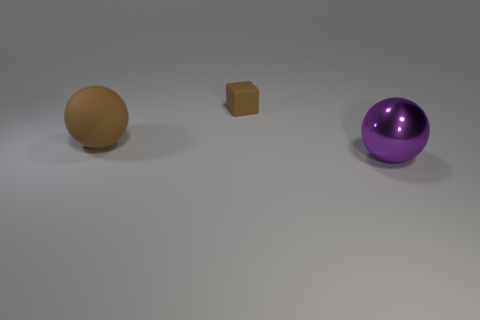Is there anything else that is made of the same material as the large purple sphere?
Your answer should be compact. No. Do the cube and the large sphere that is behind the big purple object have the same material?
Make the answer very short. Yes. How big is the thing in front of the ball to the left of the big metal sphere?
Give a very brief answer. Large. Are there any other things of the same color as the big shiny sphere?
Keep it short and to the point. No. Do the object that is to the left of the small thing and the object behind the large brown matte object have the same material?
Offer a terse response. Yes. What material is the object that is behind the purple object and in front of the tiny brown object?
Offer a terse response. Rubber. Does the purple metallic object have the same shape as the rubber object right of the brown matte sphere?
Give a very brief answer. No. What material is the big thing that is behind the big object that is to the right of the large object that is to the left of the big purple metal sphere made of?
Your answer should be compact. Rubber. What number of other objects are there of the same size as the brown cube?
Your answer should be compact. 0. Is the large matte ball the same color as the tiny object?
Give a very brief answer. Yes. 